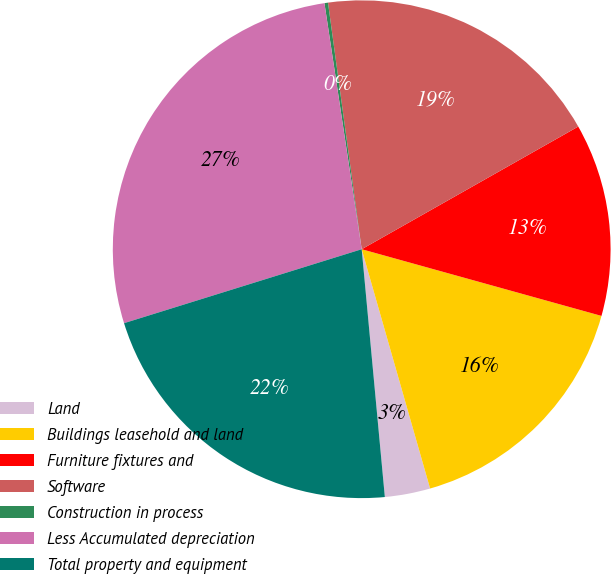Convert chart to OTSL. <chart><loc_0><loc_0><loc_500><loc_500><pie_chart><fcel>Land<fcel>Buildings leasehold and land<fcel>Furniture fixtures and<fcel>Software<fcel>Construction in process<fcel>Less Accumulated depreciation<fcel>Total property and equipment<nl><fcel>2.95%<fcel>16.25%<fcel>12.52%<fcel>18.96%<fcel>0.23%<fcel>27.41%<fcel>21.68%<nl></chart> 